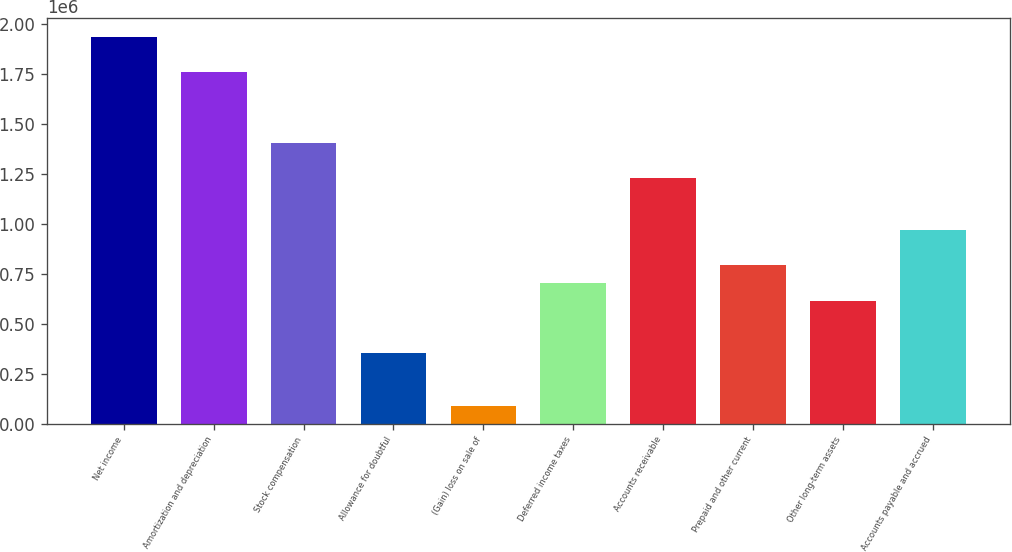Convert chart to OTSL. <chart><loc_0><loc_0><loc_500><loc_500><bar_chart><fcel>Net income<fcel>Amortization and depreciation<fcel>Stock compensation<fcel>Allowance for doubtful<fcel>(Gain) loss on sale of<fcel>Deferred income taxes<fcel>Accounts receivable<fcel>Prepaid and other current<fcel>Other long-term assets<fcel>Accounts payable and accrued<nl><fcel>1.93346e+06<fcel>1.75774e+06<fcel>1.40629e+06<fcel>351953<fcel>88367.7<fcel>703400<fcel>1.23057e+06<fcel>791261<fcel>615538<fcel>966985<nl></chart> 